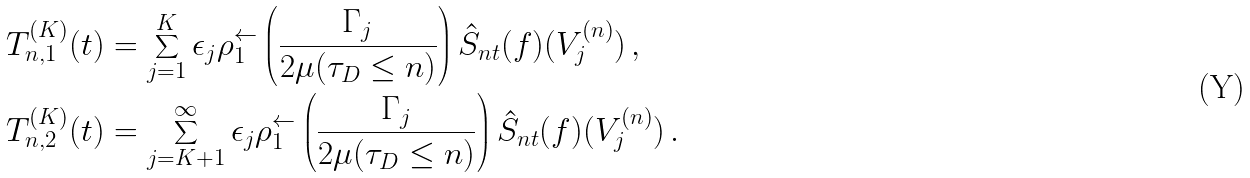Convert formula to latex. <formula><loc_0><loc_0><loc_500><loc_500>T _ { n , 1 } ^ { ( K ) } ( t ) & = \sum _ { j = 1 } ^ { K } \epsilon _ { j } \rho _ { 1 } ^ { \leftarrow } \left ( \frac { \Gamma _ { j } } { 2 \mu ( \tau _ { D } \leq n ) } \right ) \hat { S } _ { n t } ( f ) ( V _ { j } ^ { ( n ) } ) \, , \\ T _ { n , 2 } ^ { ( K ) } ( t ) & = \sum _ { j = K + 1 } ^ { \infty } \epsilon _ { j } \rho _ { 1 } ^ { \leftarrow } \left ( \frac { \Gamma _ { j } } { 2 \mu ( \tau _ { D } \leq n ) } \right ) \hat { S } _ { n t } ( f ) ( V _ { j } ^ { ( n ) } ) \, .</formula> 